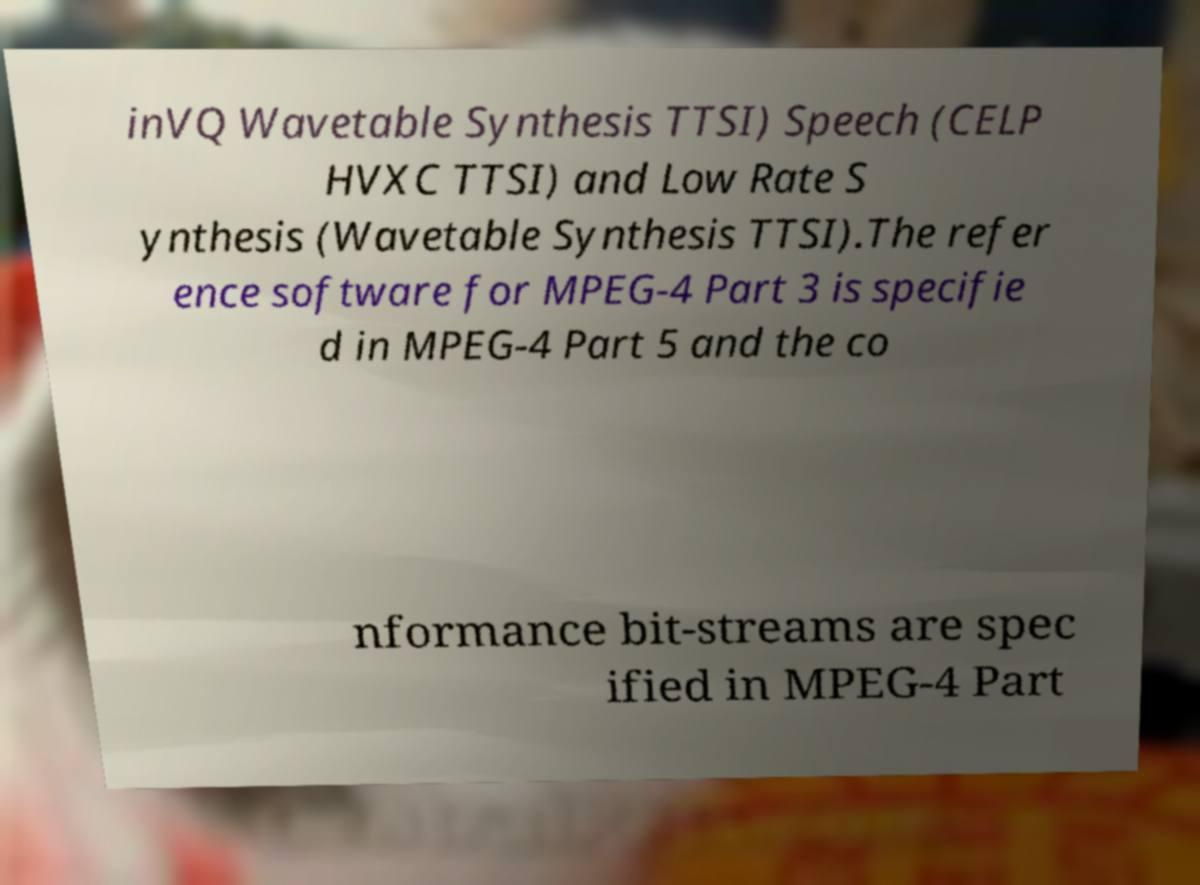Please read and relay the text visible in this image. What does it say? inVQ Wavetable Synthesis TTSI) Speech (CELP HVXC TTSI) and Low Rate S ynthesis (Wavetable Synthesis TTSI).The refer ence software for MPEG-4 Part 3 is specifie d in MPEG-4 Part 5 and the co nformance bit-streams are spec ified in MPEG-4 Part 